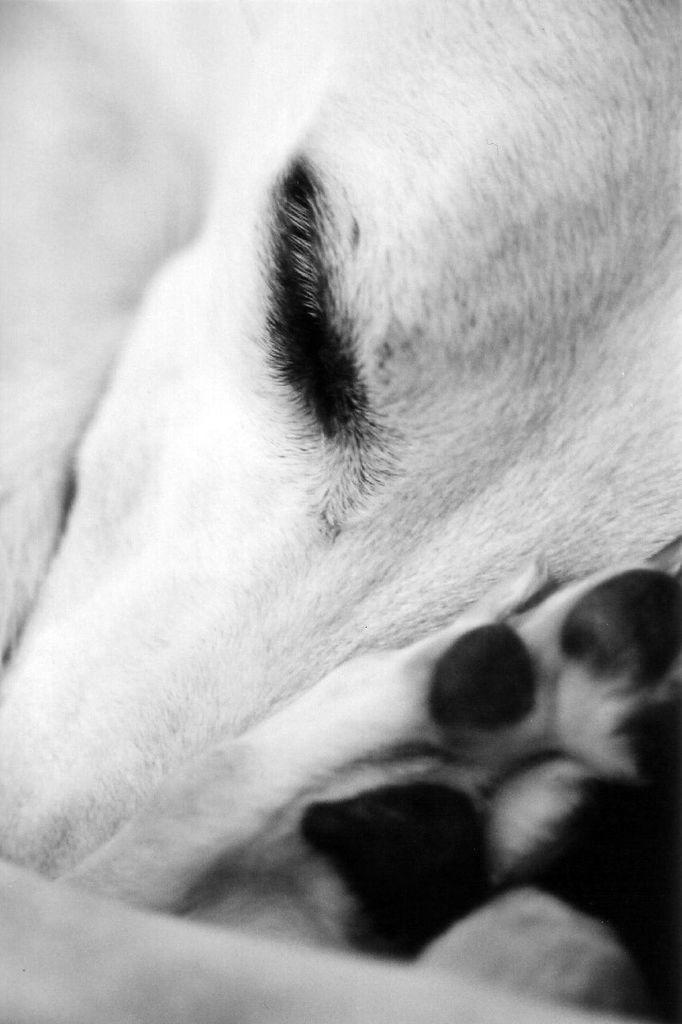What type of creature is present in the image? There is an animal in the image. Can you describe the color scheme of the image? The image is black and white in color. What type of polish is the animal using in the image? There is no polish present in the image, and the animal is not using any polish. Can you tell me what the animal is talking about in the image? The image is black and white, and there is no indication of any speech or conversation. 